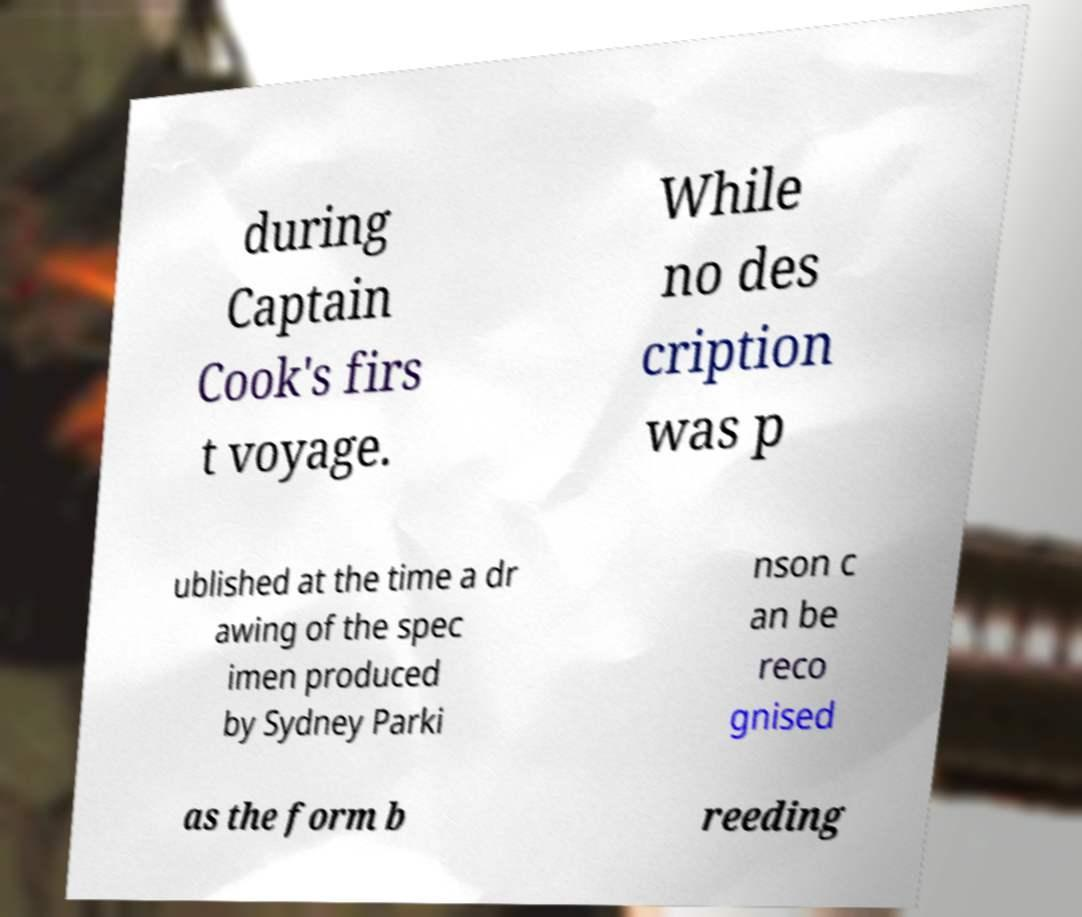What messages or text are displayed in this image? I need them in a readable, typed format. during Captain Cook's firs t voyage. While no des cription was p ublished at the time a dr awing of the spec imen produced by Sydney Parki nson c an be reco gnised as the form b reeding 